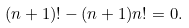Convert formula to latex. <formula><loc_0><loc_0><loc_500><loc_500>( n + 1 ) ! - ( n + 1 ) n ! = 0 .</formula> 